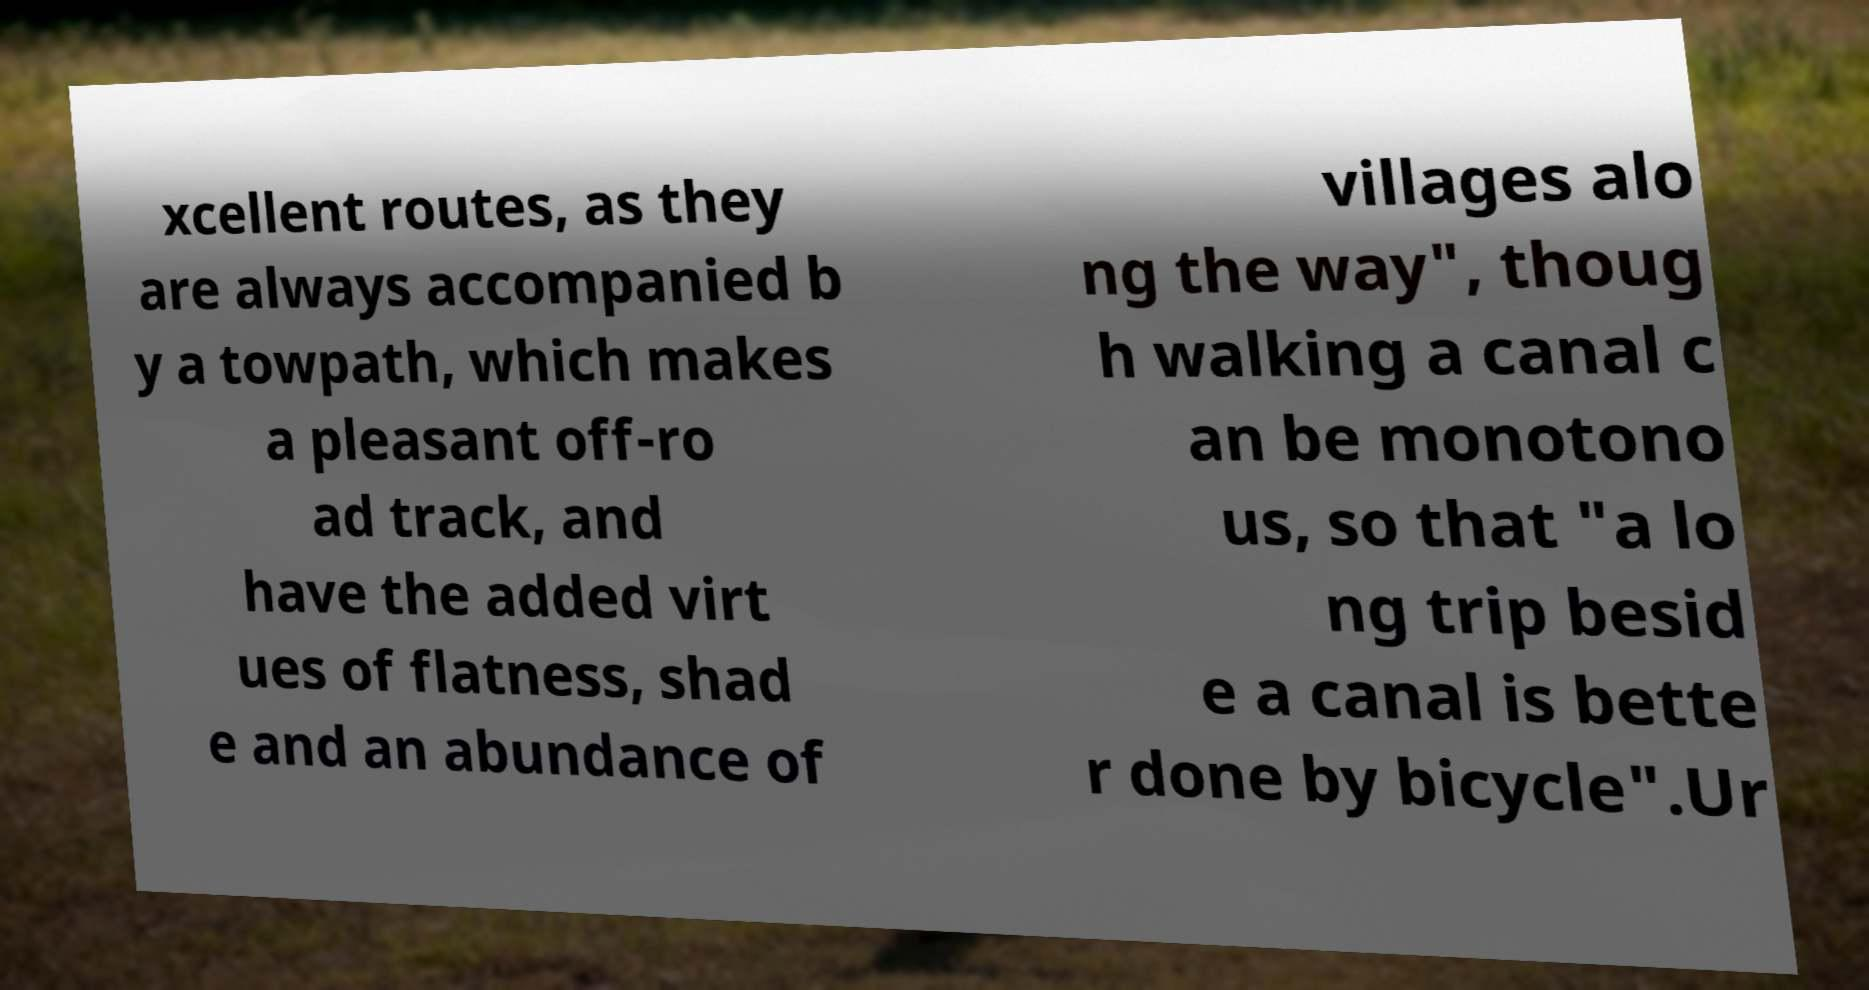Could you extract and type out the text from this image? xcellent routes, as they are always accompanied b y a towpath, which makes a pleasant off-ro ad track, and have the added virt ues of flatness, shad e and an abundance of villages alo ng the way", thoug h walking a canal c an be monotono us, so that "a lo ng trip besid e a canal is bette r done by bicycle".Ur 